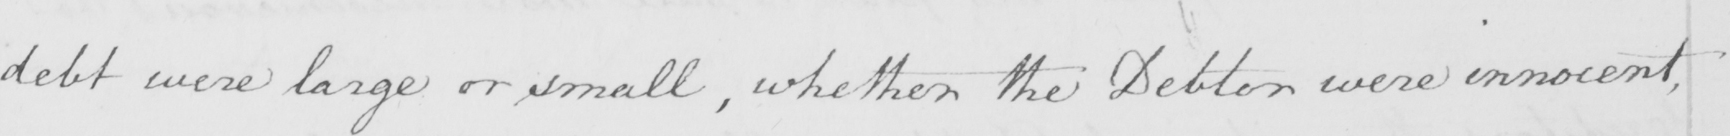What text is written in this handwritten line? debt were large or small , whether the Debtor were innocent , 